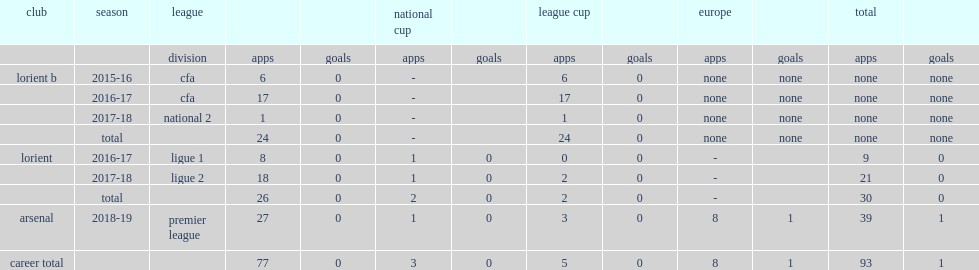In the 2017-18 season, how many times did guendouzi feature for lorient in ligue 2? 21.0. 